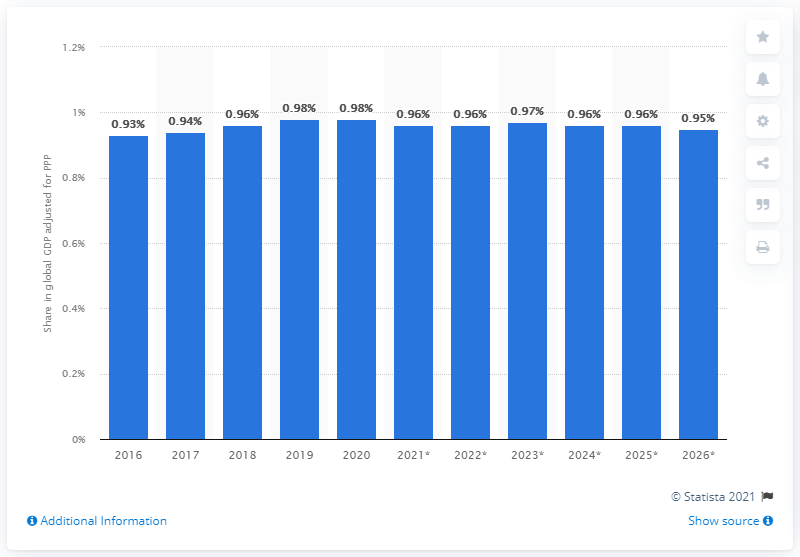Identify some key points in this picture. In 2020, Poland's share of the global Gross Domestic Product (GDP) adjusted for Purchasing Power Parity (PPP) was 0.98. 